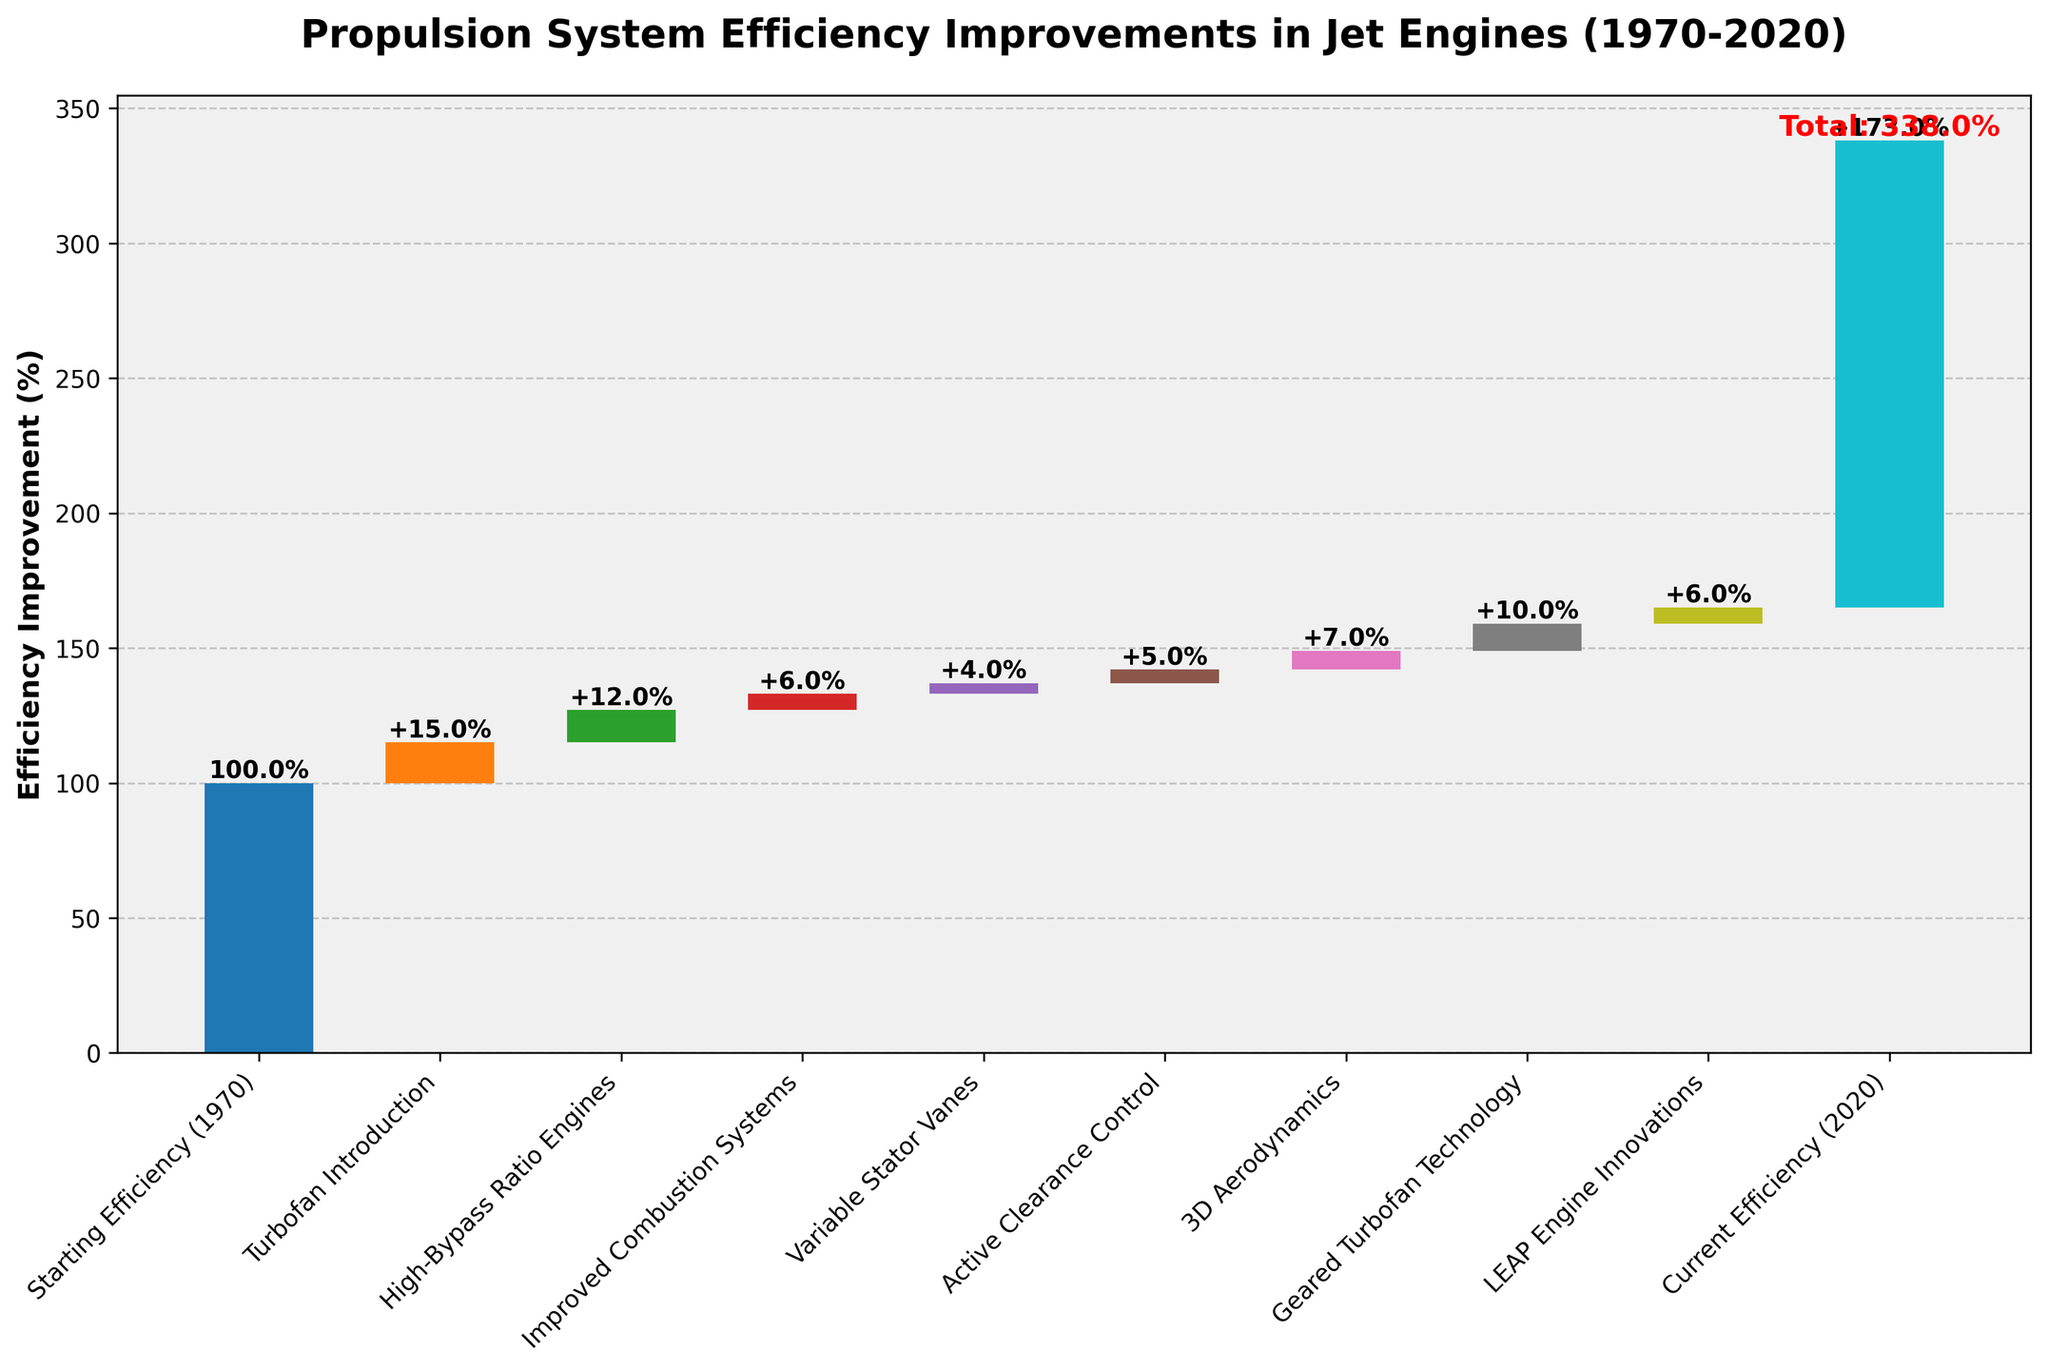what is the total improvement in efficiency from 1970 to 2020 according to the chart? The total improvement is indicated by the value label at the end of the chart in red, right above the last category "Current Efficiency (2020)". It states the total cumulative efficiency improvement.
Answer: 73% which individual innovation provided the highest efficiency improvement? By examining the vertical heights of the bars on the chart, "Turbofan Introduction" stands out with the highest value.
Answer: Turbofan Introduction how much did high-bypass ratio engines contribute to the total efficiency improvement? The individual efficiency improvement of High-Bypass Ratio Engines is indicated by the height of its bar and the value label.
Answer: 12% how do the values of 3D Aerodynamics and Active Clearance Control compare? By comparing the heights of the bars and the value labels, "3D Aerodynamics" provides a higher efficiency improvement than "Active Clearance Control".
Answer: 3D Aerodynamics > Active Clearance Control what is the difference in efficiency improvements between Turbofan Introduction and LEAP Engine Innovations? The Turbofan Introduction improved efficiency by 15%, and LEAP Engine Innovations improved it by 6%. Subtracting the smaller value from the larger gives the difference.
Answer: 9% how many distinct categories are outlined in the chart? The categories are listed along the x-axis of the chart. By counting these, we get the total number of distinct categories.
Answer: 10 in which decades were the majority of the technological improvements made? By examining the timeline from 1970 to 2020, and where most of the bars appear within the chart, it can be inferred that the substantial improvements happened post-2000.
Answer: Post-2000 what is the combined efficiency improvement of Variable Stator Vanes and Active Clearance Control? Add the individual improvements: 4% for Variable Stator Vanes and 5% for Active Clearance Control, giving a combined total.
Answer: 9% is the improvement contributed by Improved Combustion Systems greater or less than that contributed by Geared Turbofan Technology? By comparing the heights of the bars and value labels, "Improved Combustion Systems" (6%) is less than "Geared Turbofan Technology" (10%).
Answer: Less which innovation added the least to the overall efficiency improvement? From the bar heights and value labels, Active Clearance Control with 5% is the least significant improvement.
Answer: Active Clearance Control 